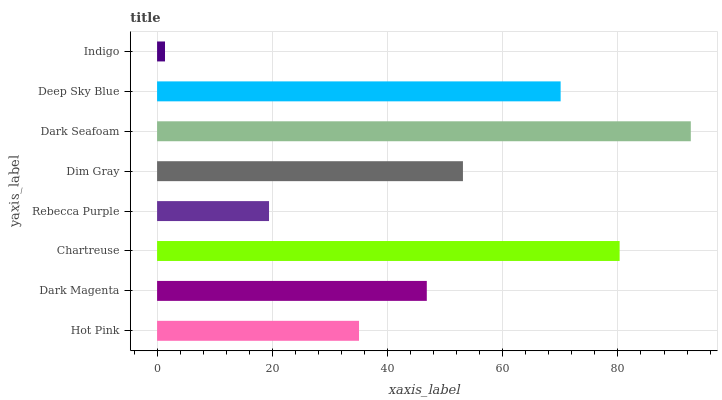Is Indigo the minimum?
Answer yes or no. Yes. Is Dark Seafoam the maximum?
Answer yes or no. Yes. Is Dark Magenta the minimum?
Answer yes or no. No. Is Dark Magenta the maximum?
Answer yes or no. No. Is Dark Magenta greater than Hot Pink?
Answer yes or no. Yes. Is Hot Pink less than Dark Magenta?
Answer yes or no. Yes. Is Hot Pink greater than Dark Magenta?
Answer yes or no. No. Is Dark Magenta less than Hot Pink?
Answer yes or no. No. Is Dim Gray the high median?
Answer yes or no. Yes. Is Dark Magenta the low median?
Answer yes or no. Yes. Is Hot Pink the high median?
Answer yes or no. No. Is Dim Gray the low median?
Answer yes or no. No. 